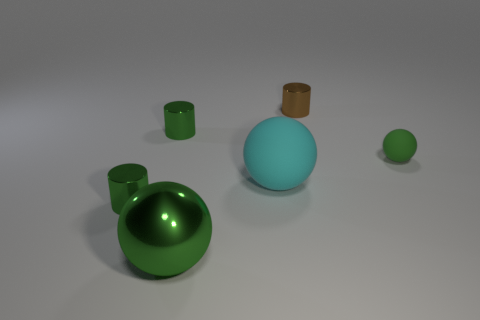What number of rubber things are large balls or blue cubes?
Offer a very short reply. 1. There is a sphere that is the same color as the large shiny object; what is it made of?
Ensure brevity in your answer.  Rubber. Are there fewer cyan objects to the right of the cyan rubber object than brown metallic things that are to the right of the brown shiny thing?
Keep it short and to the point. No. What number of things are either large purple cylinders or small cylinders that are to the left of the brown cylinder?
Provide a succinct answer. 2. What is the material of the ball that is the same size as the brown metal cylinder?
Your response must be concise. Rubber. Is the material of the big green thing the same as the tiny ball?
Offer a terse response. No. What color is the ball that is both on the left side of the small sphere and to the right of the big green metal ball?
Give a very brief answer. Cyan. Do the tiny thing that is right of the tiny brown cylinder and the large metal ball have the same color?
Keep it short and to the point. Yes. There is a brown thing that is the same size as the green matte ball; what shape is it?
Give a very brief answer. Cylinder. How many other objects are the same color as the large metallic thing?
Offer a terse response. 3. 